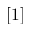Convert formula to latex. <formula><loc_0><loc_0><loc_500><loc_500>[ 1 ]</formula> 